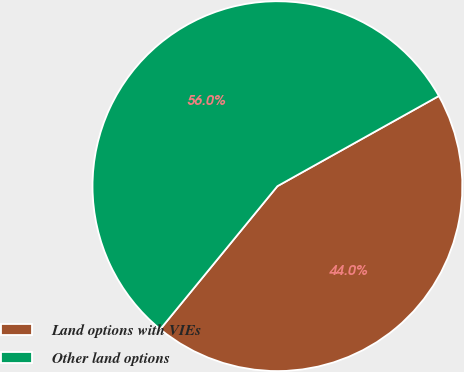Convert chart to OTSL. <chart><loc_0><loc_0><loc_500><loc_500><pie_chart><fcel>Land options with VIEs<fcel>Other land options<nl><fcel>44.03%<fcel>55.97%<nl></chart> 